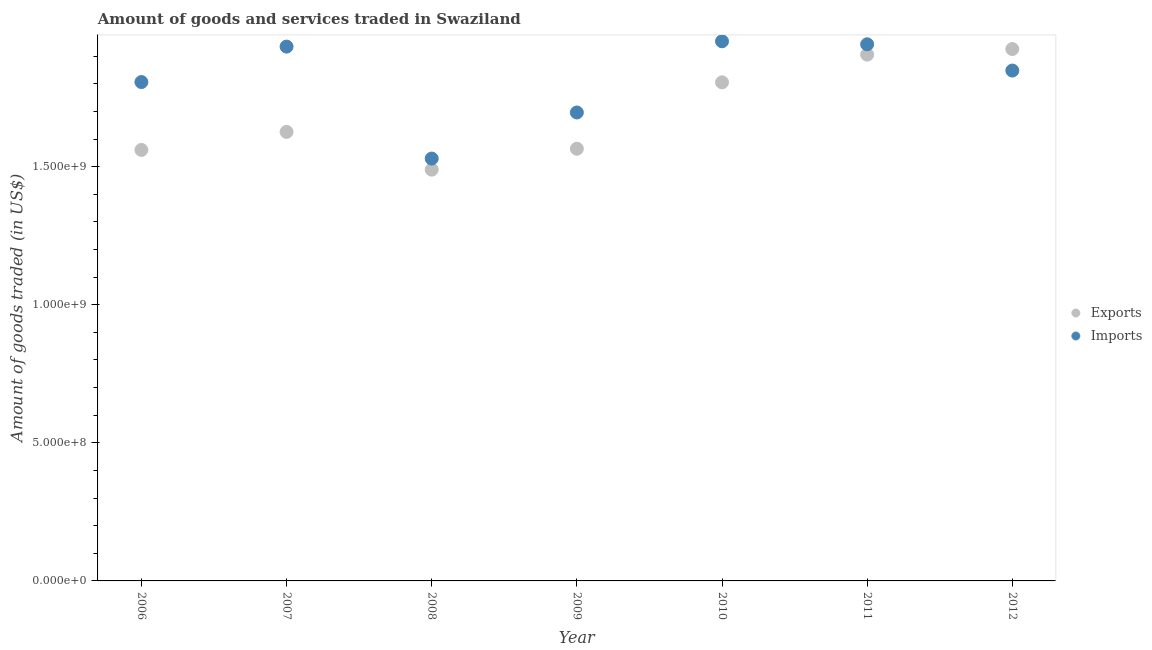Is the number of dotlines equal to the number of legend labels?
Offer a terse response. Yes. What is the amount of goods exported in 2007?
Your answer should be very brief. 1.63e+09. Across all years, what is the maximum amount of goods exported?
Offer a very short reply. 1.93e+09. Across all years, what is the minimum amount of goods exported?
Provide a succinct answer. 1.49e+09. What is the total amount of goods imported in the graph?
Your answer should be very brief. 1.27e+1. What is the difference between the amount of goods exported in 2008 and that in 2011?
Make the answer very short. -4.17e+08. What is the difference between the amount of goods exported in 2007 and the amount of goods imported in 2009?
Make the answer very short. -7.03e+07. What is the average amount of goods exported per year?
Your answer should be compact. 1.70e+09. In the year 2012, what is the difference between the amount of goods imported and amount of goods exported?
Provide a succinct answer. -7.79e+07. What is the ratio of the amount of goods exported in 2010 to that in 2012?
Your answer should be compact. 0.94. Is the difference between the amount of goods exported in 2009 and 2010 greater than the difference between the amount of goods imported in 2009 and 2010?
Keep it short and to the point. Yes. What is the difference between the highest and the second highest amount of goods exported?
Offer a terse response. 2.02e+07. What is the difference between the highest and the lowest amount of goods exported?
Keep it short and to the point. 4.37e+08. In how many years, is the amount of goods exported greater than the average amount of goods exported taken over all years?
Your answer should be compact. 3. Does the amount of goods imported monotonically increase over the years?
Provide a succinct answer. No. Is the amount of goods imported strictly greater than the amount of goods exported over the years?
Provide a short and direct response. No. Is the amount of goods imported strictly less than the amount of goods exported over the years?
Provide a short and direct response. No. What is the difference between two consecutive major ticks on the Y-axis?
Offer a very short reply. 5.00e+08. Are the values on the major ticks of Y-axis written in scientific E-notation?
Ensure brevity in your answer.  Yes. Does the graph contain any zero values?
Provide a succinct answer. No. Does the graph contain grids?
Offer a very short reply. No. Where does the legend appear in the graph?
Provide a short and direct response. Center right. What is the title of the graph?
Provide a succinct answer. Amount of goods and services traded in Swaziland. Does "Female" appear as one of the legend labels in the graph?
Make the answer very short. No. What is the label or title of the Y-axis?
Make the answer very short. Amount of goods traded (in US$). What is the Amount of goods traded (in US$) in Exports in 2006?
Ensure brevity in your answer.  1.56e+09. What is the Amount of goods traded (in US$) of Imports in 2006?
Offer a very short reply. 1.81e+09. What is the Amount of goods traded (in US$) in Exports in 2007?
Ensure brevity in your answer.  1.63e+09. What is the Amount of goods traded (in US$) in Imports in 2007?
Offer a very short reply. 1.93e+09. What is the Amount of goods traded (in US$) in Exports in 2008?
Your response must be concise. 1.49e+09. What is the Amount of goods traded (in US$) of Imports in 2008?
Provide a short and direct response. 1.53e+09. What is the Amount of goods traded (in US$) of Exports in 2009?
Offer a terse response. 1.56e+09. What is the Amount of goods traded (in US$) in Imports in 2009?
Make the answer very short. 1.70e+09. What is the Amount of goods traded (in US$) of Exports in 2010?
Offer a terse response. 1.81e+09. What is the Amount of goods traded (in US$) in Imports in 2010?
Keep it short and to the point. 1.95e+09. What is the Amount of goods traded (in US$) in Exports in 2011?
Provide a succinct answer. 1.91e+09. What is the Amount of goods traded (in US$) in Imports in 2011?
Make the answer very short. 1.94e+09. What is the Amount of goods traded (in US$) of Exports in 2012?
Offer a very short reply. 1.93e+09. What is the Amount of goods traded (in US$) in Imports in 2012?
Offer a terse response. 1.85e+09. Across all years, what is the maximum Amount of goods traded (in US$) in Exports?
Your response must be concise. 1.93e+09. Across all years, what is the maximum Amount of goods traded (in US$) of Imports?
Provide a short and direct response. 1.95e+09. Across all years, what is the minimum Amount of goods traded (in US$) in Exports?
Provide a succinct answer. 1.49e+09. Across all years, what is the minimum Amount of goods traded (in US$) of Imports?
Offer a terse response. 1.53e+09. What is the total Amount of goods traded (in US$) of Exports in the graph?
Make the answer very short. 1.19e+1. What is the total Amount of goods traded (in US$) of Imports in the graph?
Offer a very short reply. 1.27e+1. What is the difference between the Amount of goods traded (in US$) of Exports in 2006 and that in 2007?
Offer a very short reply. -6.52e+07. What is the difference between the Amount of goods traded (in US$) in Imports in 2006 and that in 2007?
Your response must be concise. -1.28e+08. What is the difference between the Amount of goods traded (in US$) of Exports in 2006 and that in 2008?
Keep it short and to the point. 7.14e+07. What is the difference between the Amount of goods traded (in US$) of Imports in 2006 and that in 2008?
Ensure brevity in your answer.  2.77e+08. What is the difference between the Amount of goods traded (in US$) in Exports in 2006 and that in 2009?
Offer a terse response. -4.34e+06. What is the difference between the Amount of goods traded (in US$) of Imports in 2006 and that in 2009?
Give a very brief answer. 1.10e+08. What is the difference between the Amount of goods traded (in US$) of Exports in 2006 and that in 2010?
Provide a succinct answer. -2.45e+08. What is the difference between the Amount of goods traded (in US$) of Imports in 2006 and that in 2010?
Make the answer very short. -1.48e+08. What is the difference between the Amount of goods traded (in US$) in Exports in 2006 and that in 2011?
Offer a terse response. -3.45e+08. What is the difference between the Amount of goods traded (in US$) in Imports in 2006 and that in 2011?
Your answer should be compact. -1.37e+08. What is the difference between the Amount of goods traded (in US$) in Exports in 2006 and that in 2012?
Offer a terse response. -3.65e+08. What is the difference between the Amount of goods traded (in US$) of Imports in 2006 and that in 2012?
Offer a very short reply. -4.16e+07. What is the difference between the Amount of goods traded (in US$) in Exports in 2007 and that in 2008?
Provide a succinct answer. 1.37e+08. What is the difference between the Amount of goods traded (in US$) of Imports in 2007 and that in 2008?
Ensure brevity in your answer.  4.05e+08. What is the difference between the Amount of goods traded (in US$) of Exports in 2007 and that in 2009?
Keep it short and to the point. 6.09e+07. What is the difference between the Amount of goods traded (in US$) of Imports in 2007 and that in 2009?
Keep it short and to the point. 2.39e+08. What is the difference between the Amount of goods traded (in US$) in Exports in 2007 and that in 2010?
Provide a succinct answer. -1.79e+08. What is the difference between the Amount of goods traded (in US$) of Imports in 2007 and that in 2010?
Ensure brevity in your answer.  -1.93e+07. What is the difference between the Amount of goods traded (in US$) of Exports in 2007 and that in 2011?
Offer a terse response. -2.80e+08. What is the difference between the Amount of goods traded (in US$) of Imports in 2007 and that in 2011?
Make the answer very short. -8.34e+06. What is the difference between the Amount of goods traded (in US$) in Exports in 2007 and that in 2012?
Your answer should be compact. -3.00e+08. What is the difference between the Amount of goods traded (in US$) of Imports in 2007 and that in 2012?
Provide a short and direct response. 8.67e+07. What is the difference between the Amount of goods traded (in US$) of Exports in 2008 and that in 2009?
Your answer should be compact. -7.58e+07. What is the difference between the Amount of goods traded (in US$) in Imports in 2008 and that in 2009?
Offer a terse response. -1.67e+08. What is the difference between the Amount of goods traded (in US$) of Exports in 2008 and that in 2010?
Your answer should be very brief. -3.16e+08. What is the difference between the Amount of goods traded (in US$) of Imports in 2008 and that in 2010?
Ensure brevity in your answer.  -4.25e+08. What is the difference between the Amount of goods traded (in US$) in Exports in 2008 and that in 2011?
Keep it short and to the point. -4.17e+08. What is the difference between the Amount of goods traded (in US$) in Imports in 2008 and that in 2011?
Provide a succinct answer. -4.14e+08. What is the difference between the Amount of goods traded (in US$) in Exports in 2008 and that in 2012?
Offer a very short reply. -4.37e+08. What is the difference between the Amount of goods traded (in US$) in Imports in 2008 and that in 2012?
Give a very brief answer. -3.19e+08. What is the difference between the Amount of goods traded (in US$) in Exports in 2009 and that in 2010?
Provide a short and direct response. -2.40e+08. What is the difference between the Amount of goods traded (in US$) in Imports in 2009 and that in 2010?
Provide a short and direct response. -2.58e+08. What is the difference between the Amount of goods traded (in US$) of Exports in 2009 and that in 2011?
Offer a terse response. -3.41e+08. What is the difference between the Amount of goods traded (in US$) in Imports in 2009 and that in 2011?
Your answer should be compact. -2.47e+08. What is the difference between the Amount of goods traded (in US$) in Exports in 2009 and that in 2012?
Offer a very short reply. -3.61e+08. What is the difference between the Amount of goods traded (in US$) of Imports in 2009 and that in 2012?
Ensure brevity in your answer.  -1.52e+08. What is the difference between the Amount of goods traded (in US$) in Exports in 2010 and that in 2011?
Your response must be concise. -1.00e+08. What is the difference between the Amount of goods traded (in US$) in Imports in 2010 and that in 2011?
Keep it short and to the point. 1.09e+07. What is the difference between the Amount of goods traded (in US$) in Exports in 2010 and that in 2012?
Offer a very short reply. -1.21e+08. What is the difference between the Amount of goods traded (in US$) of Imports in 2010 and that in 2012?
Provide a short and direct response. 1.06e+08. What is the difference between the Amount of goods traded (in US$) of Exports in 2011 and that in 2012?
Ensure brevity in your answer.  -2.02e+07. What is the difference between the Amount of goods traded (in US$) of Imports in 2011 and that in 2012?
Your answer should be very brief. 9.50e+07. What is the difference between the Amount of goods traded (in US$) in Exports in 2006 and the Amount of goods traded (in US$) in Imports in 2007?
Your answer should be very brief. -3.74e+08. What is the difference between the Amount of goods traded (in US$) of Exports in 2006 and the Amount of goods traded (in US$) of Imports in 2008?
Make the answer very short. 3.13e+07. What is the difference between the Amount of goods traded (in US$) of Exports in 2006 and the Amount of goods traded (in US$) of Imports in 2009?
Make the answer very short. -1.36e+08. What is the difference between the Amount of goods traded (in US$) of Exports in 2006 and the Amount of goods traded (in US$) of Imports in 2010?
Your answer should be compact. -3.93e+08. What is the difference between the Amount of goods traded (in US$) in Exports in 2006 and the Amount of goods traded (in US$) in Imports in 2011?
Ensure brevity in your answer.  -3.82e+08. What is the difference between the Amount of goods traded (in US$) of Exports in 2006 and the Amount of goods traded (in US$) of Imports in 2012?
Give a very brief answer. -2.87e+08. What is the difference between the Amount of goods traded (in US$) of Exports in 2007 and the Amount of goods traded (in US$) of Imports in 2008?
Your response must be concise. 9.66e+07. What is the difference between the Amount of goods traded (in US$) of Exports in 2007 and the Amount of goods traded (in US$) of Imports in 2009?
Your answer should be very brief. -7.03e+07. What is the difference between the Amount of goods traded (in US$) of Exports in 2007 and the Amount of goods traded (in US$) of Imports in 2010?
Your response must be concise. -3.28e+08. What is the difference between the Amount of goods traded (in US$) of Exports in 2007 and the Amount of goods traded (in US$) of Imports in 2011?
Your response must be concise. -3.17e+08. What is the difference between the Amount of goods traded (in US$) of Exports in 2007 and the Amount of goods traded (in US$) of Imports in 2012?
Your answer should be compact. -2.22e+08. What is the difference between the Amount of goods traded (in US$) of Exports in 2008 and the Amount of goods traded (in US$) of Imports in 2009?
Your response must be concise. -2.07e+08. What is the difference between the Amount of goods traded (in US$) of Exports in 2008 and the Amount of goods traded (in US$) of Imports in 2010?
Your answer should be compact. -4.65e+08. What is the difference between the Amount of goods traded (in US$) in Exports in 2008 and the Amount of goods traded (in US$) in Imports in 2011?
Your answer should be very brief. -4.54e+08. What is the difference between the Amount of goods traded (in US$) of Exports in 2008 and the Amount of goods traded (in US$) of Imports in 2012?
Provide a short and direct response. -3.59e+08. What is the difference between the Amount of goods traded (in US$) of Exports in 2009 and the Amount of goods traded (in US$) of Imports in 2010?
Offer a terse response. -3.89e+08. What is the difference between the Amount of goods traded (in US$) of Exports in 2009 and the Amount of goods traded (in US$) of Imports in 2011?
Your response must be concise. -3.78e+08. What is the difference between the Amount of goods traded (in US$) of Exports in 2009 and the Amount of goods traded (in US$) of Imports in 2012?
Keep it short and to the point. -2.83e+08. What is the difference between the Amount of goods traded (in US$) of Exports in 2010 and the Amount of goods traded (in US$) of Imports in 2011?
Ensure brevity in your answer.  -1.38e+08. What is the difference between the Amount of goods traded (in US$) of Exports in 2010 and the Amount of goods traded (in US$) of Imports in 2012?
Your answer should be very brief. -4.27e+07. What is the difference between the Amount of goods traded (in US$) of Exports in 2011 and the Amount of goods traded (in US$) of Imports in 2012?
Provide a short and direct response. 5.77e+07. What is the average Amount of goods traded (in US$) in Exports per year?
Offer a very short reply. 1.70e+09. What is the average Amount of goods traded (in US$) in Imports per year?
Provide a short and direct response. 1.82e+09. In the year 2006, what is the difference between the Amount of goods traded (in US$) in Exports and Amount of goods traded (in US$) in Imports?
Make the answer very short. -2.46e+08. In the year 2007, what is the difference between the Amount of goods traded (in US$) in Exports and Amount of goods traded (in US$) in Imports?
Ensure brevity in your answer.  -3.09e+08. In the year 2008, what is the difference between the Amount of goods traded (in US$) of Exports and Amount of goods traded (in US$) of Imports?
Your answer should be compact. -4.01e+07. In the year 2009, what is the difference between the Amount of goods traded (in US$) of Exports and Amount of goods traded (in US$) of Imports?
Offer a very short reply. -1.31e+08. In the year 2010, what is the difference between the Amount of goods traded (in US$) in Exports and Amount of goods traded (in US$) in Imports?
Provide a short and direct response. -1.49e+08. In the year 2011, what is the difference between the Amount of goods traded (in US$) in Exports and Amount of goods traded (in US$) in Imports?
Ensure brevity in your answer.  -3.73e+07. In the year 2012, what is the difference between the Amount of goods traded (in US$) of Exports and Amount of goods traded (in US$) of Imports?
Your response must be concise. 7.79e+07. What is the ratio of the Amount of goods traded (in US$) in Exports in 2006 to that in 2007?
Your answer should be very brief. 0.96. What is the ratio of the Amount of goods traded (in US$) of Imports in 2006 to that in 2007?
Your answer should be very brief. 0.93. What is the ratio of the Amount of goods traded (in US$) in Exports in 2006 to that in 2008?
Your answer should be very brief. 1.05. What is the ratio of the Amount of goods traded (in US$) of Imports in 2006 to that in 2008?
Your answer should be very brief. 1.18. What is the ratio of the Amount of goods traded (in US$) of Exports in 2006 to that in 2009?
Your answer should be compact. 1. What is the ratio of the Amount of goods traded (in US$) in Imports in 2006 to that in 2009?
Provide a short and direct response. 1.06. What is the ratio of the Amount of goods traded (in US$) of Exports in 2006 to that in 2010?
Offer a very short reply. 0.86. What is the ratio of the Amount of goods traded (in US$) of Imports in 2006 to that in 2010?
Offer a very short reply. 0.92. What is the ratio of the Amount of goods traded (in US$) in Exports in 2006 to that in 2011?
Offer a terse response. 0.82. What is the ratio of the Amount of goods traded (in US$) in Imports in 2006 to that in 2011?
Provide a short and direct response. 0.93. What is the ratio of the Amount of goods traded (in US$) of Exports in 2006 to that in 2012?
Your answer should be compact. 0.81. What is the ratio of the Amount of goods traded (in US$) in Imports in 2006 to that in 2012?
Your answer should be very brief. 0.98. What is the ratio of the Amount of goods traded (in US$) in Exports in 2007 to that in 2008?
Provide a succinct answer. 1.09. What is the ratio of the Amount of goods traded (in US$) of Imports in 2007 to that in 2008?
Your response must be concise. 1.27. What is the ratio of the Amount of goods traded (in US$) of Exports in 2007 to that in 2009?
Make the answer very short. 1.04. What is the ratio of the Amount of goods traded (in US$) of Imports in 2007 to that in 2009?
Make the answer very short. 1.14. What is the ratio of the Amount of goods traded (in US$) in Exports in 2007 to that in 2010?
Ensure brevity in your answer.  0.9. What is the ratio of the Amount of goods traded (in US$) in Exports in 2007 to that in 2011?
Provide a succinct answer. 0.85. What is the ratio of the Amount of goods traded (in US$) of Exports in 2007 to that in 2012?
Your response must be concise. 0.84. What is the ratio of the Amount of goods traded (in US$) in Imports in 2007 to that in 2012?
Your answer should be very brief. 1.05. What is the ratio of the Amount of goods traded (in US$) of Exports in 2008 to that in 2009?
Offer a very short reply. 0.95. What is the ratio of the Amount of goods traded (in US$) in Imports in 2008 to that in 2009?
Provide a succinct answer. 0.9. What is the ratio of the Amount of goods traded (in US$) in Exports in 2008 to that in 2010?
Make the answer very short. 0.82. What is the ratio of the Amount of goods traded (in US$) of Imports in 2008 to that in 2010?
Ensure brevity in your answer.  0.78. What is the ratio of the Amount of goods traded (in US$) of Exports in 2008 to that in 2011?
Give a very brief answer. 0.78. What is the ratio of the Amount of goods traded (in US$) of Imports in 2008 to that in 2011?
Ensure brevity in your answer.  0.79. What is the ratio of the Amount of goods traded (in US$) of Exports in 2008 to that in 2012?
Give a very brief answer. 0.77. What is the ratio of the Amount of goods traded (in US$) of Imports in 2008 to that in 2012?
Offer a very short reply. 0.83. What is the ratio of the Amount of goods traded (in US$) of Exports in 2009 to that in 2010?
Make the answer very short. 0.87. What is the ratio of the Amount of goods traded (in US$) in Imports in 2009 to that in 2010?
Keep it short and to the point. 0.87. What is the ratio of the Amount of goods traded (in US$) in Exports in 2009 to that in 2011?
Offer a very short reply. 0.82. What is the ratio of the Amount of goods traded (in US$) of Imports in 2009 to that in 2011?
Make the answer very short. 0.87. What is the ratio of the Amount of goods traded (in US$) in Exports in 2009 to that in 2012?
Your response must be concise. 0.81. What is the ratio of the Amount of goods traded (in US$) in Imports in 2009 to that in 2012?
Offer a very short reply. 0.92. What is the ratio of the Amount of goods traded (in US$) in Exports in 2010 to that in 2011?
Offer a terse response. 0.95. What is the ratio of the Amount of goods traded (in US$) in Imports in 2010 to that in 2011?
Ensure brevity in your answer.  1.01. What is the ratio of the Amount of goods traded (in US$) in Exports in 2010 to that in 2012?
Your answer should be very brief. 0.94. What is the ratio of the Amount of goods traded (in US$) of Imports in 2010 to that in 2012?
Keep it short and to the point. 1.06. What is the ratio of the Amount of goods traded (in US$) in Exports in 2011 to that in 2012?
Your answer should be compact. 0.99. What is the ratio of the Amount of goods traded (in US$) of Imports in 2011 to that in 2012?
Your response must be concise. 1.05. What is the difference between the highest and the second highest Amount of goods traded (in US$) of Exports?
Your answer should be compact. 2.02e+07. What is the difference between the highest and the second highest Amount of goods traded (in US$) in Imports?
Your answer should be very brief. 1.09e+07. What is the difference between the highest and the lowest Amount of goods traded (in US$) of Exports?
Provide a succinct answer. 4.37e+08. What is the difference between the highest and the lowest Amount of goods traded (in US$) of Imports?
Give a very brief answer. 4.25e+08. 